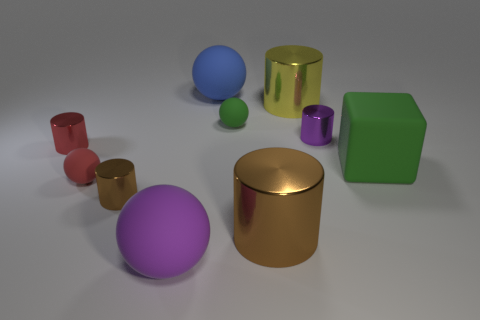What is the color of the other large object that is the same shape as the blue rubber object?
Provide a succinct answer. Purple. There is a small brown thing; is its shape the same as the large metallic object in front of the tiny red shiny object?
Offer a very short reply. Yes. Is there a big red shiny object that has the same shape as the blue rubber thing?
Offer a terse response. No. Are there any small brown cylinders behind the yellow metallic cylinder that is right of the red rubber thing?
Provide a short and direct response. No. How many objects are either metallic things that are on the right side of the big yellow cylinder or green matte things that are left of the large brown metal cylinder?
Make the answer very short. 2. What number of things are either small cyan matte cylinders or objects that are on the right side of the small brown metallic object?
Ensure brevity in your answer.  7. There is a metal cylinder that is behind the small metallic cylinder that is right of the small thing in front of the red sphere; what size is it?
Ensure brevity in your answer.  Large. What material is the brown thing that is the same size as the blue ball?
Your answer should be compact. Metal. Are there any other balls that have the same size as the blue ball?
Provide a succinct answer. Yes. There is a purple thing that is behind the red rubber thing; is it the same size as the large yellow thing?
Offer a very short reply. No. 